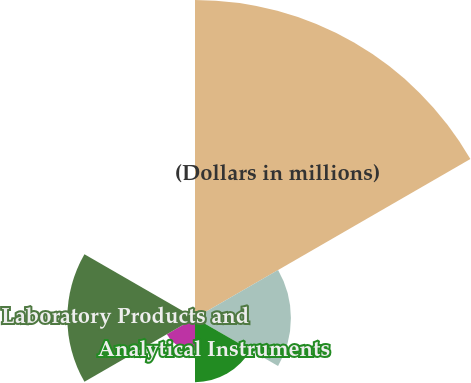<chart> <loc_0><loc_0><loc_500><loc_500><pie_chart><fcel>(Dollars in millions)<fcel>Life Sciences Solutions<fcel>Analytical Instruments<fcel>Specialty Diagnostics<fcel>Laboratory Products and<fcel>Eliminations<nl><fcel>49.77%<fcel>15.01%<fcel>10.05%<fcel>5.08%<fcel>19.98%<fcel>0.12%<nl></chart> 